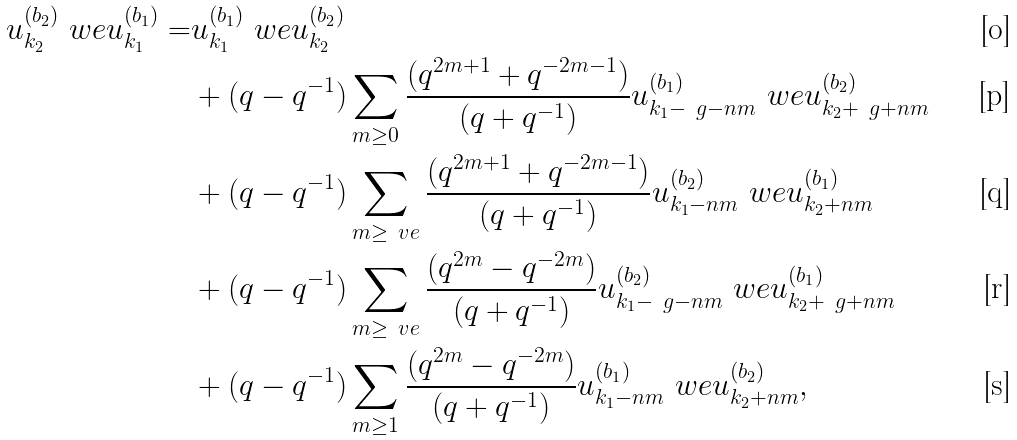<formula> <loc_0><loc_0><loc_500><loc_500>u _ { k _ { 2 } } ^ { ( b _ { 2 } ) } \ w e u _ { k _ { 1 } } ^ { ( b _ { 1 } ) } = & u _ { k _ { 1 } } ^ { ( b _ { 1 } ) } \ w e u _ { k _ { 2 } } ^ { ( b _ { 2 } ) } \\ & + ( q - q ^ { - 1 } ) \sum _ { m \geq 0 } \frac { ( q ^ { 2 m + 1 } + q ^ { - 2 m - 1 } ) } { ( q + q ^ { - 1 } ) } u _ { k _ { 1 } - \ g - n m } ^ { ( b _ { 1 } ) } \ w e u _ { k _ { 2 } + \ g + n m } ^ { ( b _ { 2 } ) } \\ & + ( q - q ^ { - 1 } ) \sum _ { m \geq \ v e } \frac { ( q ^ { 2 m + 1 } + q ^ { - 2 m - 1 } ) } { ( q + q ^ { - 1 } ) } u _ { k _ { 1 } - n m } ^ { ( b _ { 2 } ) } \ w e u _ { k _ { 2 } + n m } ^ { ( b _ { 1 } ) } \\ & + ( q - q ^ { - 1 } ) \sum _ { m \geq \ v e } \frac { ( q ^ { 2 m } - q ^ { - 2 m } ) } { ( q + q ^ { - 1 } ) } u _ { k _ { 1 } - \ g - n m } ^ { ( b _ { 2 } ) } \ w e u _ { k _ { 2 } + \ g + n m } ^ { ( b _ { 1 } ) } \\ & + ( q - q ^ { - 1 } ) \sum _ { m \geq 1 } \frac { ( q ^ { 2 m } - q ^ { - 2 m } ) } { ( q + q ^ { - 1 } ) } u _ { k _ { 1 } - n m } ^ { ( b _ { 1 } ) } \ w e u _ { k _ { 2 } + n m } ^ { ( b _ { 2 } ) } ,</formula> 